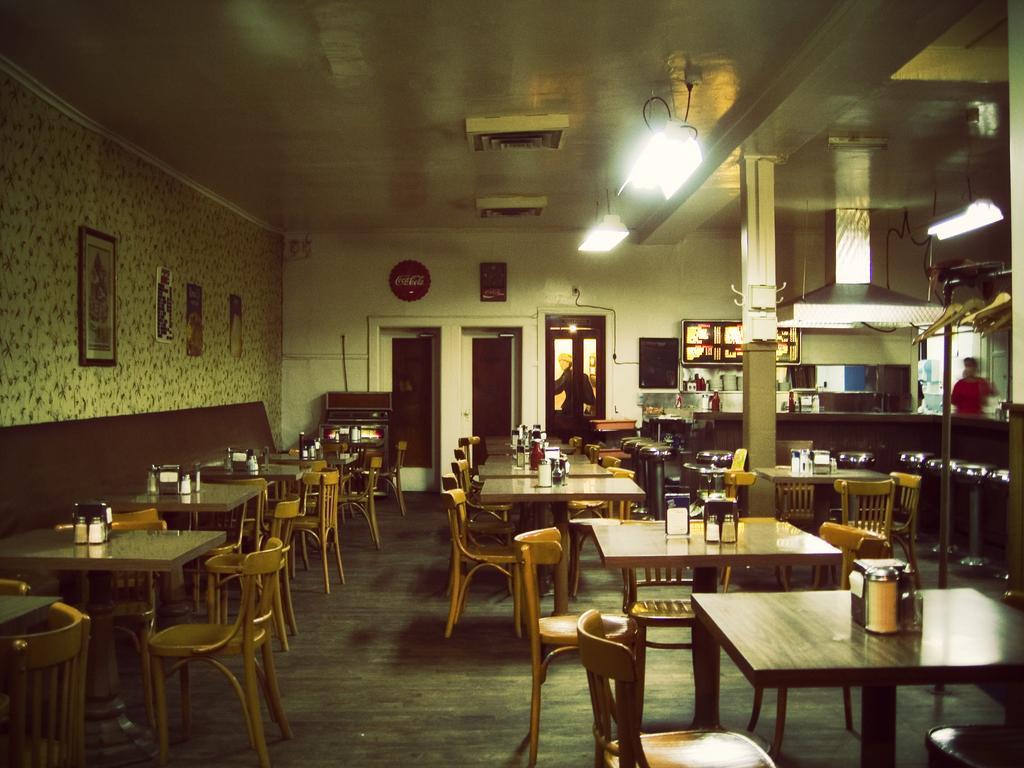Describe this image in one or two sentences. In this image I see number of tables on which there are few things and I see the chairs and I can also see the stools over here and I see the floor. In the background I see the wall on which there are frames and I see a person over here and I see the lights on the ceiling and I can also see a door over here and a person behind it. 